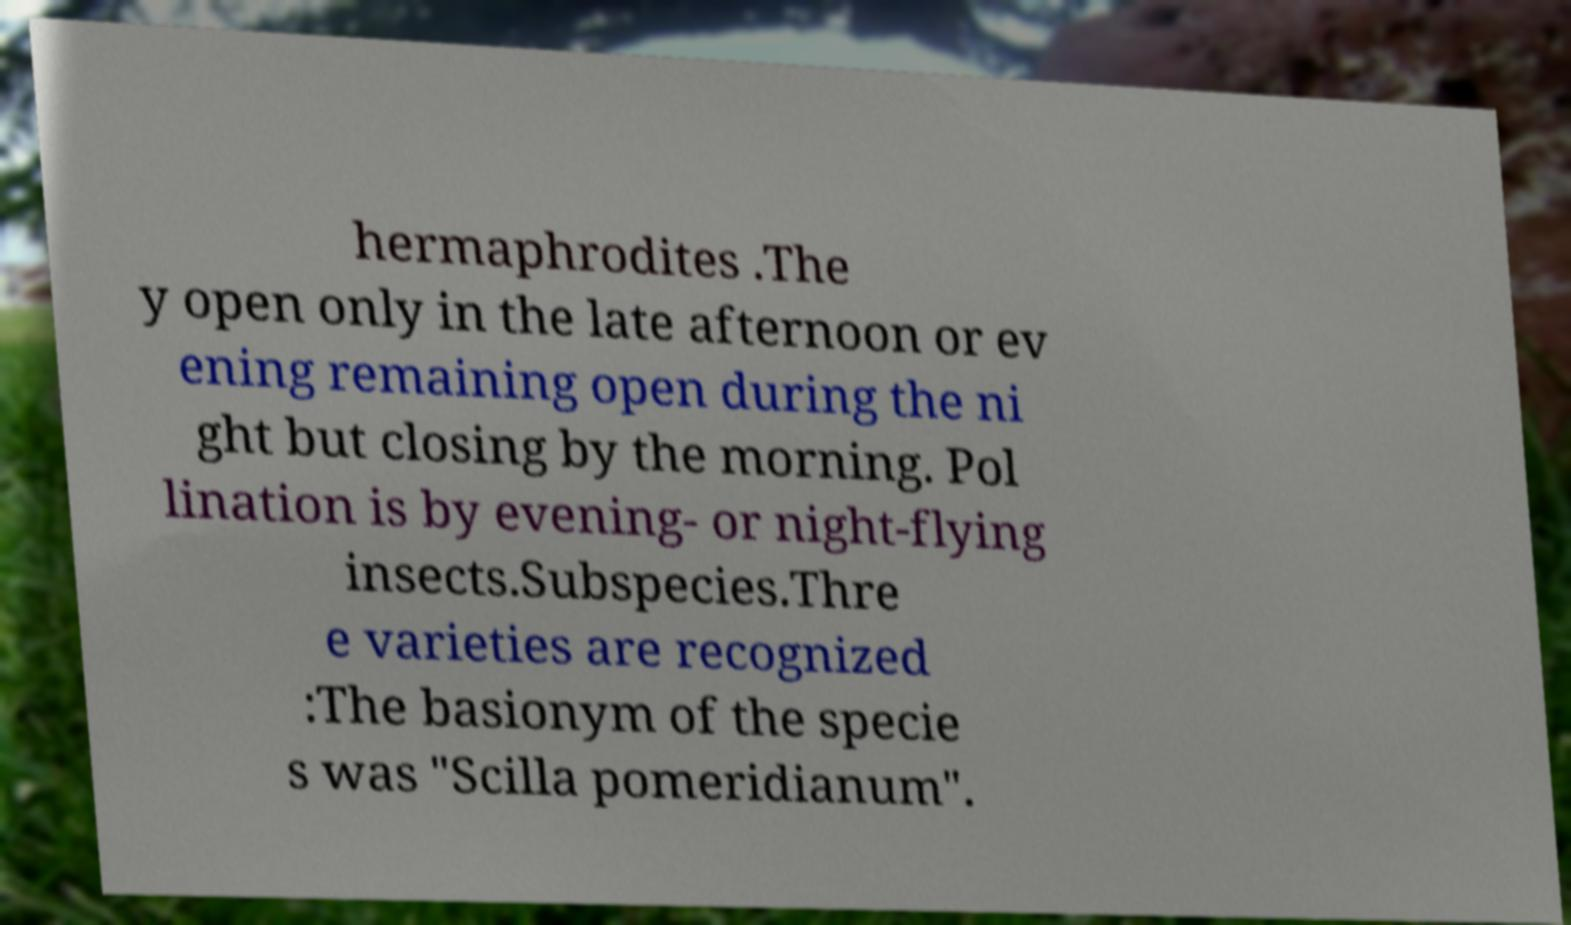Please read and relay the text visible in this image. What does it say? hermaphrodites .The y open only in the late afternoon or ev ening remaining open during the ni ght but closing by the morning. Pol lination is by evening- or night-flying insects.Subspecies.Thre e varieties are recognized :The basionym of the specie s was "Scilla pomeridianum". 